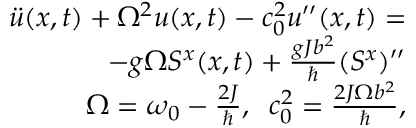<formula> <loc_0><loc_0><loc_500><loc_500>\begin{array} { r l r } & { \ddot { u } ( x , t ) + \Omega ^ { 2 } u ( x , t ) - c _ { 0 } ^ { 2 } u ^ { \prime \prime } ( x , t ) = } \\ & { - g \Omega S ^ { x } ( x , t ) + \frac { g J b ^ { 2 } } { } ( S ^ { x } ) ^ { \prime \prime } } \\ & { \Omega = \omega _ { 0 } - \frac { 2 J } { } , \, c _ { 0 } ^ { 2 } = \frac { 2 J \Omega b ^ { 2 } } { } , } \end{array}</formula> 